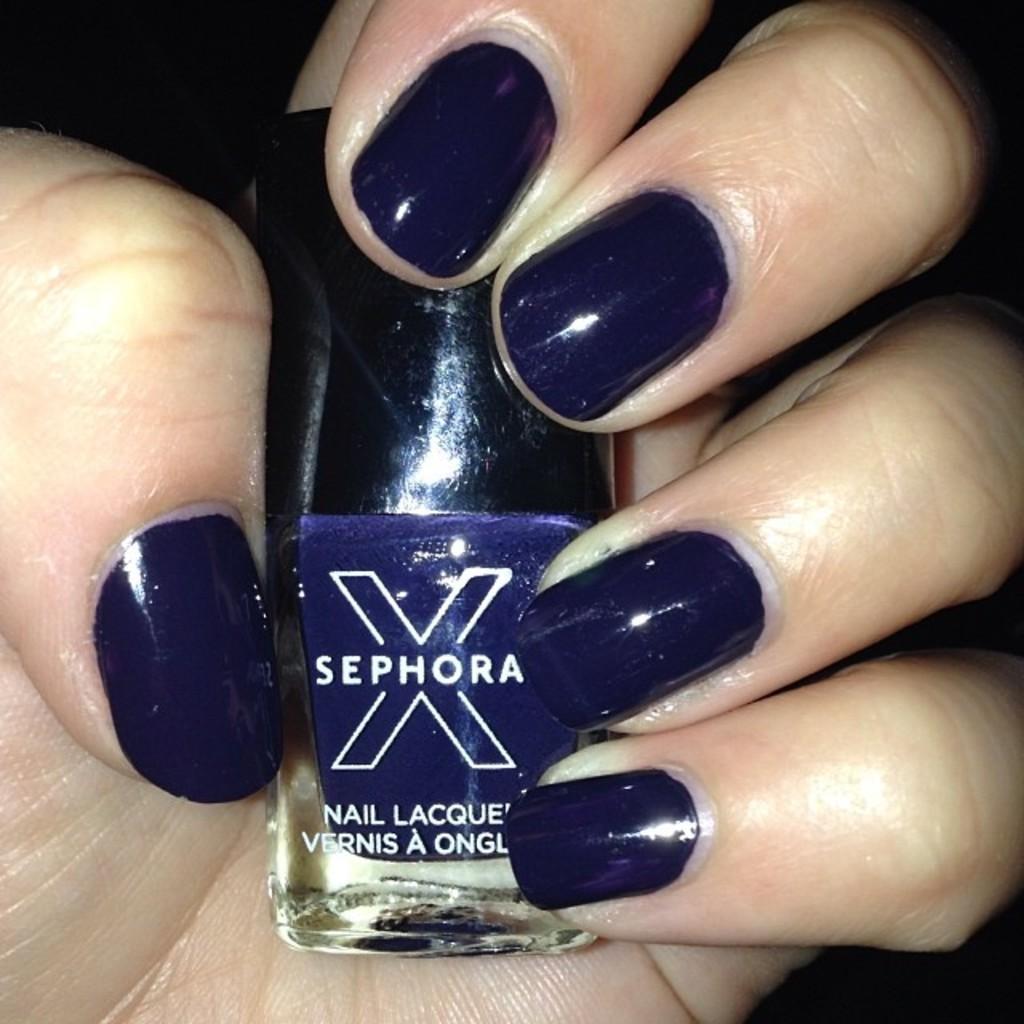Describe this image in one or two sentences. As we can see in the image there is a human hand holding blue color nail polish and for the fingers there is a nail polish. 